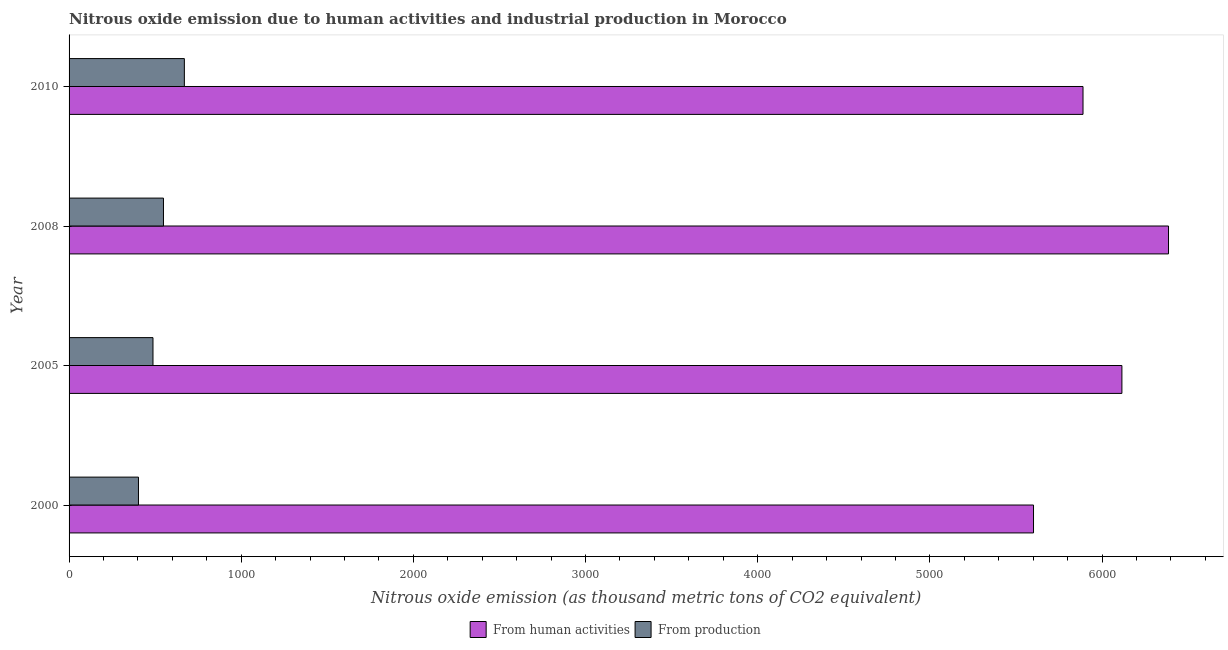Are the number of bars per tick equal to the number of legend labels?
Provide a short and direct response. Yes. Are the number of bars on each tick of the Y-axis equal?
Offer a very short reply. Yes. How many bars are there on the 4th tick from the top?
Keep it short and to the point. 2. In how many cases, is the number of bars for a given year not equal to the number of legend labels?
Give a very brief answer. 0. What is the amount of emissions generated from industries in 2005?
Your answer should be very brief. 487.4. Across all years, what is the maximum amount of emissions generated from industries?
Provide a short and direct response. 669.7. Across all years, what is the minimum amount of emissions generated from industries?
Your answer should be compact. 403.1. In which year was the amount of emissions generated from industries minimum?
Offer a very short reply. 2000. What is the total amount of emissions from human activities in the graph?
Offer a terse response. 2.40e+04. What is the difference between the amount of emissions from human activities in 2008 and that in 2010?
Your response must be concise. 496.7. What is the difference between the amount of emissions generated from industries in 2005 and the amount of emissions from human activities in 2010?
Make the answer very short. -5402.1. What is the average amount of emissions from human activities per year?
Offer a very short reply. 5998.27. In the year 2008, what is the difference between the amount of emissions generated from industries and amount of emissions from human activities?
Your answer should be very brief. -5837.9. What is the ratio of the amount of emissions generated from industries in 2005 to that in 2010?
Make the answer very short. 0.73. What is the difference between the highest and the second highest amount of emissions generated from industries?
Offer a very short reply. 121.4. What is the difference between the highest and the lowest amount of emissions from human activities?
Keep it short and to the point. 784.2. What does the 2nd bar from the top in 2000 represents?
Make the answer very short. From human activities. What does the 1st bar from the bottom in 2000 represents?
Offer a very short reply. From human activities. Are all the bars in the graph horizontal?
Give a very brief answer. Yes. What is the difference between two consecutive major ticks on the X-axis?
Give a very brief answer. 1000. Does the graph contain grids?
Keep it short and to the point. No. What is the title of the graph?
Offer a very short reply. Nitrous oxide emission due to human activities and industrial production in Morocco. What is the label or title of the X-axis?
Your response must be concise. Nitrous oxide emission (as thousand metric tons of CO2 equivalent). What is the Nitrous oxide emission (as thousand metric tons of CO2 equivalent) of From human activities in 2000?
Give a very brief answer. 5602. What is the Nitrous oxide emission (as thousand metric tons of CO2 equivalent) in From production in 2000?
Provide a short and direct response. 403.1. What is the Nitrous oxide emission (as thousand metric tons of CO2 equivalent) of From human activities in 2005?
Your answer should be compact. 6115.4. What is the Nitrous oxide emission (as thousand metric tons of CO2 equivalent) of From production in 2005?
Keep it short and to the point. 487.4. What is the Nitrous oxide emission (as thousand metric tons of CO2 equivalent) of From human activities in 2008?
Offer a terse response. 6386.2. What is the Nitrous oxide emission (as thousand metric tons of CO2 equivalent) in From production in 2008?
Offer a terse response. 548.3. What is the Nitrous oxide emission (as thousand metric tons of CO2 equivalent) in From human activities in 2010?
Offer a very short reply. 5889.5. What is the Nitrous oxide emission (as thousand metric tons of CO2 equivalent) in From production in 2010?
Your answer should be compact. 669.7. Across all years, what is the maximum Nitrous oxide emission (as thousand metric tons of CO2 equivalent) of From human activities?
Your response must be concise. 6386.2. Across all years, what is the maximum Nitrous oxide emission (as thousand metric tons of CO2 equivalent) in From production?
Provide a short and direct response. 669.7. Across all years, what is the minimum Nitrous oxide emission (as thousand metric tons of CO2 equivalent) in From human activities?
Offer a very short reply. 5602. Across all years, what is the minimum Nitrous oxide emission (as thousand metric tons of CO2 equivalent) in From production?
Your answer should be compact. 403.1. What is the total Nitrous oxide emission (as thousand metric tons of CO2 equivalent) in From human activities in the graph?
Make the answer very short. 2.40e+04. What is the total Nitrous oxide emission (as thousand metric tons of CO2 equivalent) of From production in the graph?
Your response must be concise. 2108.5. What is the difference between the Nitrous oxide emission (as thousand metric tons of CO2 equivalent) in From human activities in 2000 and that in 2005?
Offer a very short reply. -513.4. What is the difference between the Nitrous oxide emission (as thousand metric tons of CO2 equivalent) in From production in 2000 and that in 2005?
Ensure brevity in your answer.  -84.3. What is the difference between the Nitrous oxide emission (as thousand metric tons of CO2 equivalent) in From human activities in 2000 and that in 2008?
Make the answer very short. -784.2. What is the difference between the Nitrous oxide emission (as thousand metric tons of CO2 equivalent) of From production in 2000 and that in 2008?
Keep it short and to the point. -145.2. What is the difference between the Nitrous oxide emission (as thousand metric tons of CO2 equivalent) of From human activities in 2000 and that in 2010?
Ensure brevity in your answer.  -287.5. What is the difference between the Nitrous oxide emission (as thousand metric tons of CO2 equivalent) in From production in 2000 and that in 2010?
Your response must be concise. -266.6. What is the difference between the Nitrous oxide emission (as thousand metric tons of CO2 equivalent) of From human activities in 2005 and that in 2008?
Make the answer very short. -270.8. What is the difference between the Nitrous oxide emission (as thousand metric tons of CO2 equivalent) of From production in 2005 and that in 2008?
Make the answer very short. -60.9. What is the difference between the Nitrous oxide emission (as thousand metric tons of CO2 equivalent) in From human activities in 2005 and that in 2010?
Your answer should be compact. 225.9. What is the difference between the Nitrous oxide emission (as thousand metric tons of CO2 equivalent) in From production in 2005 and that in 2010?
Give a very brief answer. -182.3. What is the difference between the Nitrous oxide emission (as thousand metric tons of CO2 equivalent) in From human activities in 2008 and that in 2010?
Your answer should be compact. 496.7. What is the difference between the Nitrous oxide emission (as thousand metric tons of CO2 equivalent) of From production in 2008 and that in 2010?
Keep it short and to the point. -121.4. What is the difference between the Nitrous oxide emission (as thousand metric tons of CO2 equivalent) in From human activities in 2000 and the Nitrous oxide emission (as thousand metric tons of CO2 equivalent) in From production in 2005?
Make the answer very short. 5114.6. What is the difference between the Nitrous oxide emission (as thousand metric tons of CO2 equivalent) in From human activities in 2000 and the Nitrous oxide emission (as thousand metric tons of CO2 equivalent) in From production in 2008?
Your answer should be very brief. 5053.7. What is the difference between the Nitrous oxide emission (as thousand metric tons of CO2 equivalent) of From human activities in 2000 and the Nitrous oxide emission (as thousand metric tons of CO2 equivalent) of From production in 2010?
Your response must be concise. 4932.3. What is the difference between the Nitrous oxide emission (as thousand metric tons of CO2 equivalent) in From human activities in 2005 and the Nitrous oxide emission (as thousand metric tons of CO2 equivalent) in From production in 2008?
Keep it short and to the point. 5567.1. What is the difference between the Nitrous oxide emission (as thousand metric tons of CO2 equivalent) in From human activities in 2005 and the Nitrous oxide emission (as thousand metric tons of CO2 equivalent) in From production in 2010?
Offer a terse response. 5445.7. What is the difference between the Nitrous oxide emission (as thousand metric tons of CO2 equivalent) of From human activities in 2008 and the Nitrous oxide emission (as thousand metric tons of CO2 equivalent) of From production in 2010?
Offer a very short reply. 5716.5. What is the average Nitrous oxide emission (as thousand metric tons of CO2 equivalent) in From human activities per year?
Make the answer very short. 5998.27. What is the average Nitrous oxide emission (as thousand metric tons of CO2 equivalent) of From production per year?
Give a very brief answer. 527.12. In the year 2000, what is the difference between the Nitrous oxide emission (as thousand metric tons of CO2 equivalent) of From human activities and Nitrous oxide emission (as thousand metric tons of CO2 equivalent) of From production?
Make the answer very short. 5198.9. In the year 2005, what is the difference between the Nitrous oxide emission (as thousand metric tons of CO2 equivalent) in From human activities and Nitrous oxide emission (as thousand metric tons of CO2 equivalent) in From production?
Provide a succinct answer. 5628. In the year 2008, what is the difference between the Nitrous oxide emission (as thousand metric tons of CO2 equivalent) in From human activities and Nitrous oxide emission (as thousand metric tons of CO2 equivalent) in From production?
Keep it short and to the point. 5837.9. In the year 2010, what is the difference between the Nitrous oxide emission (as thousand metric tons of CO2 equivalent) in From human activities and Nitrous oxide emission (as thousand metric tons of CO2 equivalent) in From production?
Give a very brief answer. 5219.8. What is the ratio of the Nitrous oxide emission (as thousand metric tons of CO2 equivalent) in From human activities in 2000 to that in 2005?
Provide a short and direct response. 0.92. What is the ratio of the Nitrous oxide emission (as thousand metric tons of CO2 equivalent) in From production in 2000 to that in 2005?
Provide a short and direct response. 0.83. What is the ratio of the Nitrous oxide emission (as thousand metric tons of CO2 equivalent) in From human activities in 2000 to that in 2008?
Your response must be concise. 0.88. What is the ratio of the Nitrous oxide emission (as thousand metric tons of CO2 equivalent) of From production in 2000 to that in 2008?
Offer a terse response. 0.74. What is the ratio of the Nitrous oxide emission (as thousand metric tons of CO2 equivalent) in From human activities in 2000 to that in 2010?
Offer a terse response. 0.95. What is the ratio of the Nitrous oxide emission (as thousand metric tons of CO2 equivalent) of From production in 2000 to that in 2010?
Your response must be concise. 0.6. What is the ratio of the Nitrous oxide emission (as thousand metric tons of CO2 equivalent) in From human activities in 2005 to that in 2008?
Make the answer very short. 0.96. What is the ratio of the Nitrous oxide emission (as thousand metric tons of CO2 equivalent) in From production in 2005 to that in 2008?
Ensure brevity in your answer.  0.89. What is the ratio of the Nitrous oxide emission (as thousand metric tons of CO2 equivalent) of From human activities in 2005 to that in 2010?
Keep it short and to the point. 1.04. What is the ratio of the Nitrous oxide emission (as thousand metric tons of CO2 equivalent) in From production in 2005 to that in 2010?
Keep it short and to the point. 0.73. What is the ratio of the Nitrous oxide emission (as thousand metric tons of CO2 equivalent) of From human activities in 2008 to that in 2010?
Ensure brevity in your answer.  1.08. What is the ratio of the Nitrous oxide emission (as thousand metric tons of CO2 equivalent) in From production in 2008 to that in 2010?
Keep it short and to the point. 0.82. What is the difference between the highest and the second highest Nitrous oxide emission (as thousand metric tons of CO2 equivalent) of From human activities?
Ensure brevity in your answer.  270.8. What is the difference between the highest and the second highest Nitrous oxide emission (as thousand metric tons of CO2 equivalent) of From production?
Your answer should be very brief. 121.4. What is the difference between the highest and the lowest Nitrous oxide emission (as thousand metric tons of CO2 equivalent) in From human activities?
Offer a very short reply. 784.2. What is the difference between the highest and the lowest Nitrous oxide emission (as thousand metric tons of CO2 equivalent) in From production?
Offer a very short reply. 266.6. 